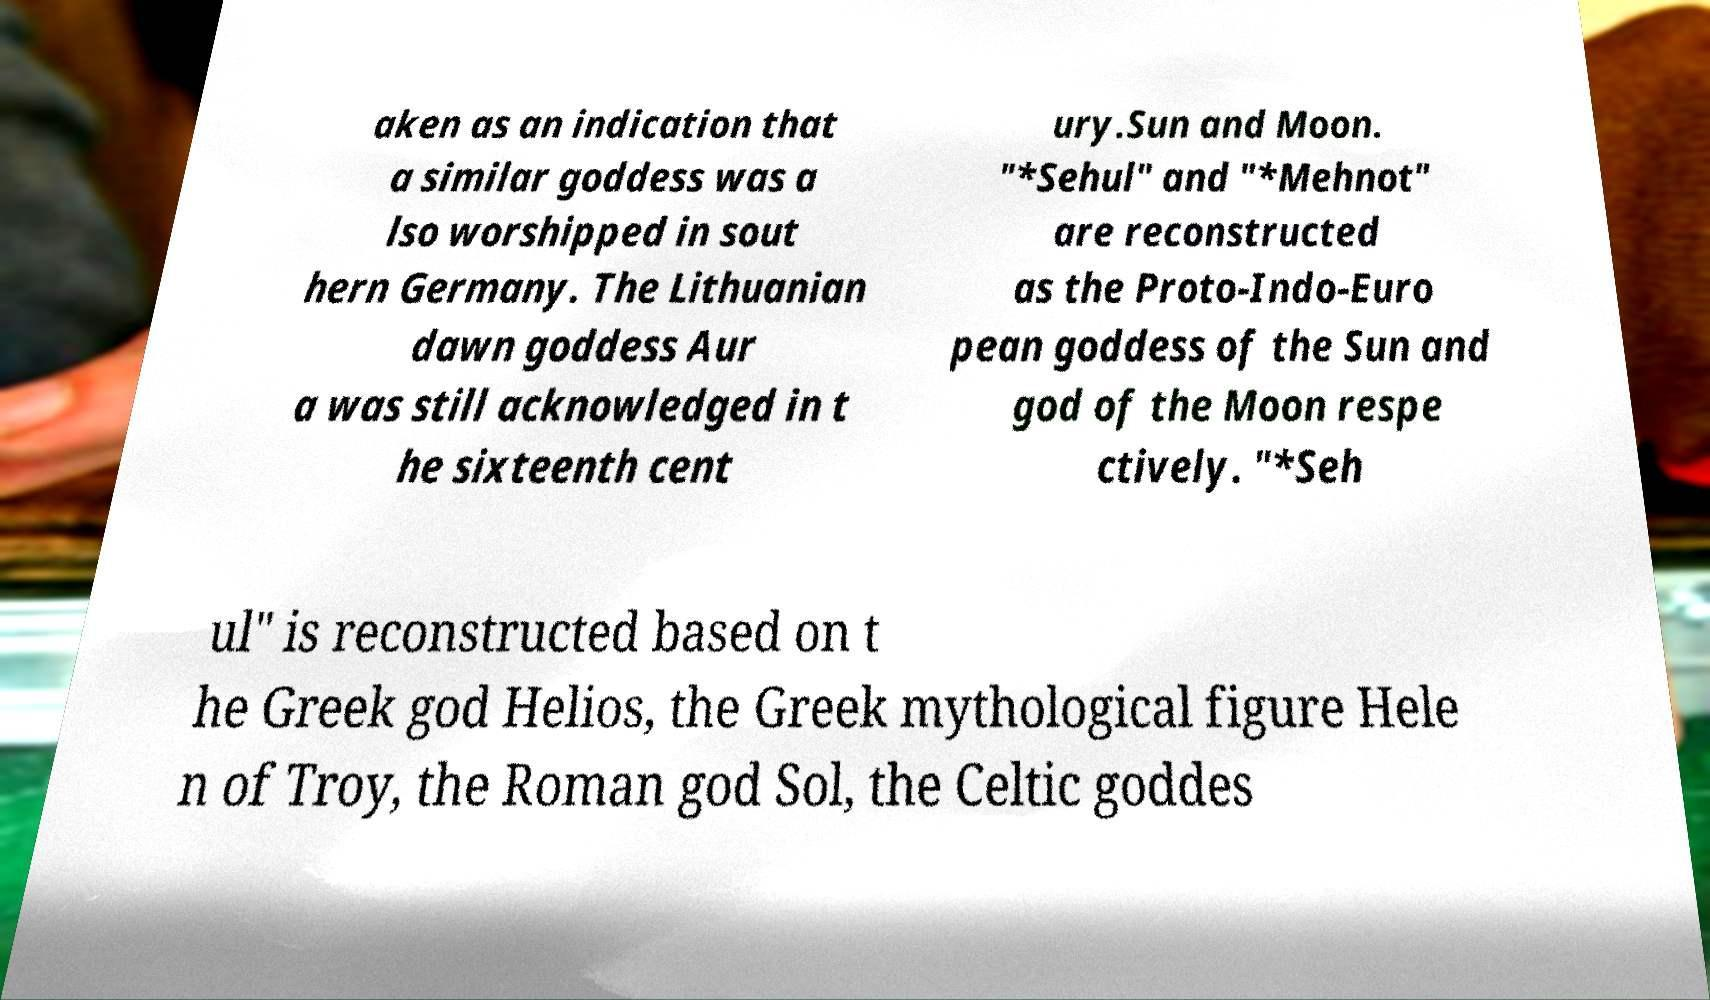Please read and relay the text visible in this image. What does it say? aken as an indication that a similar goddess was a lso worshipped in sout hern Germany. The Lithuanian dawn goddess Aur a was still acknowledged in t he sixteenth cent ury.Sun and Moon. "*Sehul" and "*Mehnot" are reconstructed as the Proto-Indo-Euro pean goddess of the Sun and god of the Moon respe ctively. "*Seh ul" is reconstructed based on t he Greek god Helios, the Greek mythological figure Hele n of Troy, the Roman god Sol, the Celtic goddes 